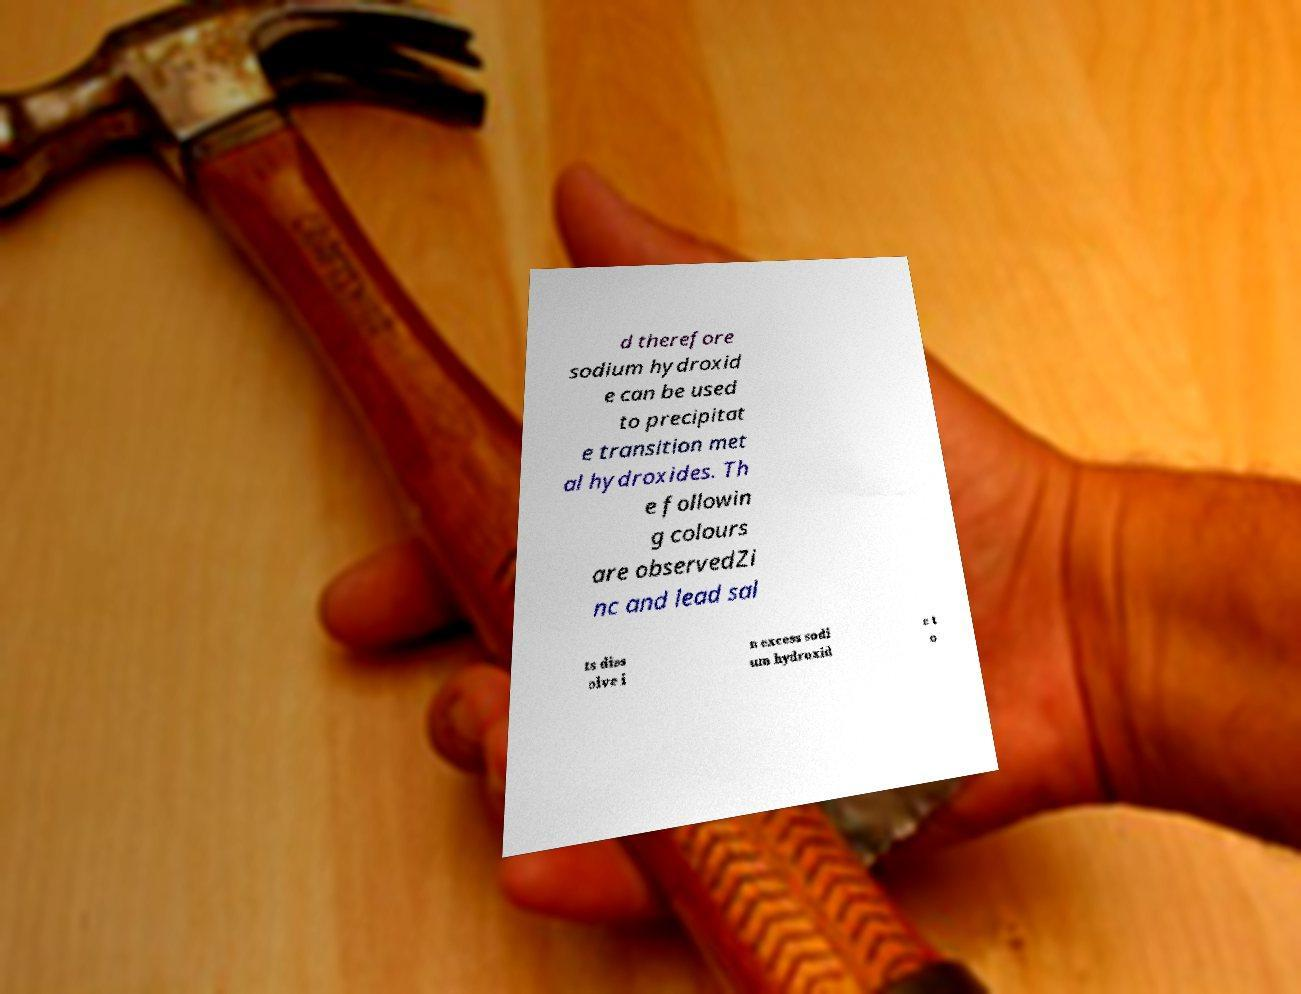I need the written content from this picture converted into text. Can you do that? d therefore sodium hydroxid e can be used to precipitat e transition met al hydroxides. Th e followin g colours are observedZi nc and lead sal ts diss olve i n excess sodi um hydroxid e t o 